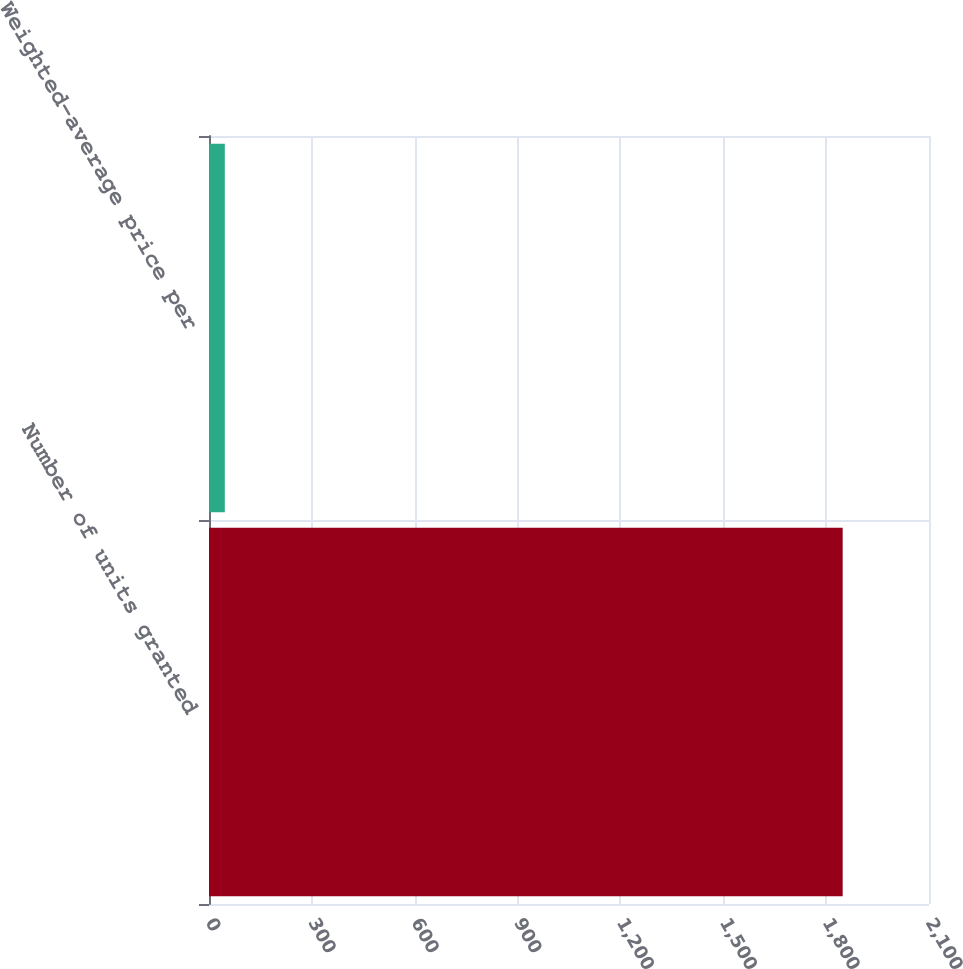<chart> <loc_0><loc_0><loc_500><loc_500><bar_chart><fcel>Number of units granted<fcel>Weighted-average price per<nl><fcel>1848.2<fcel>46.14<nl></chart> 